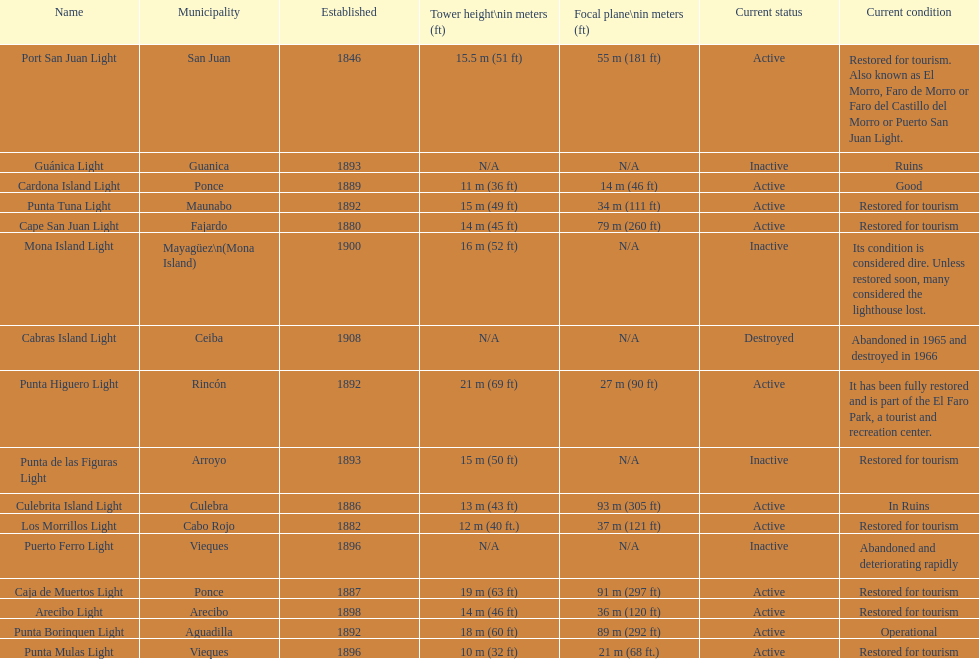How many establishments are restored for tourism? 9. 